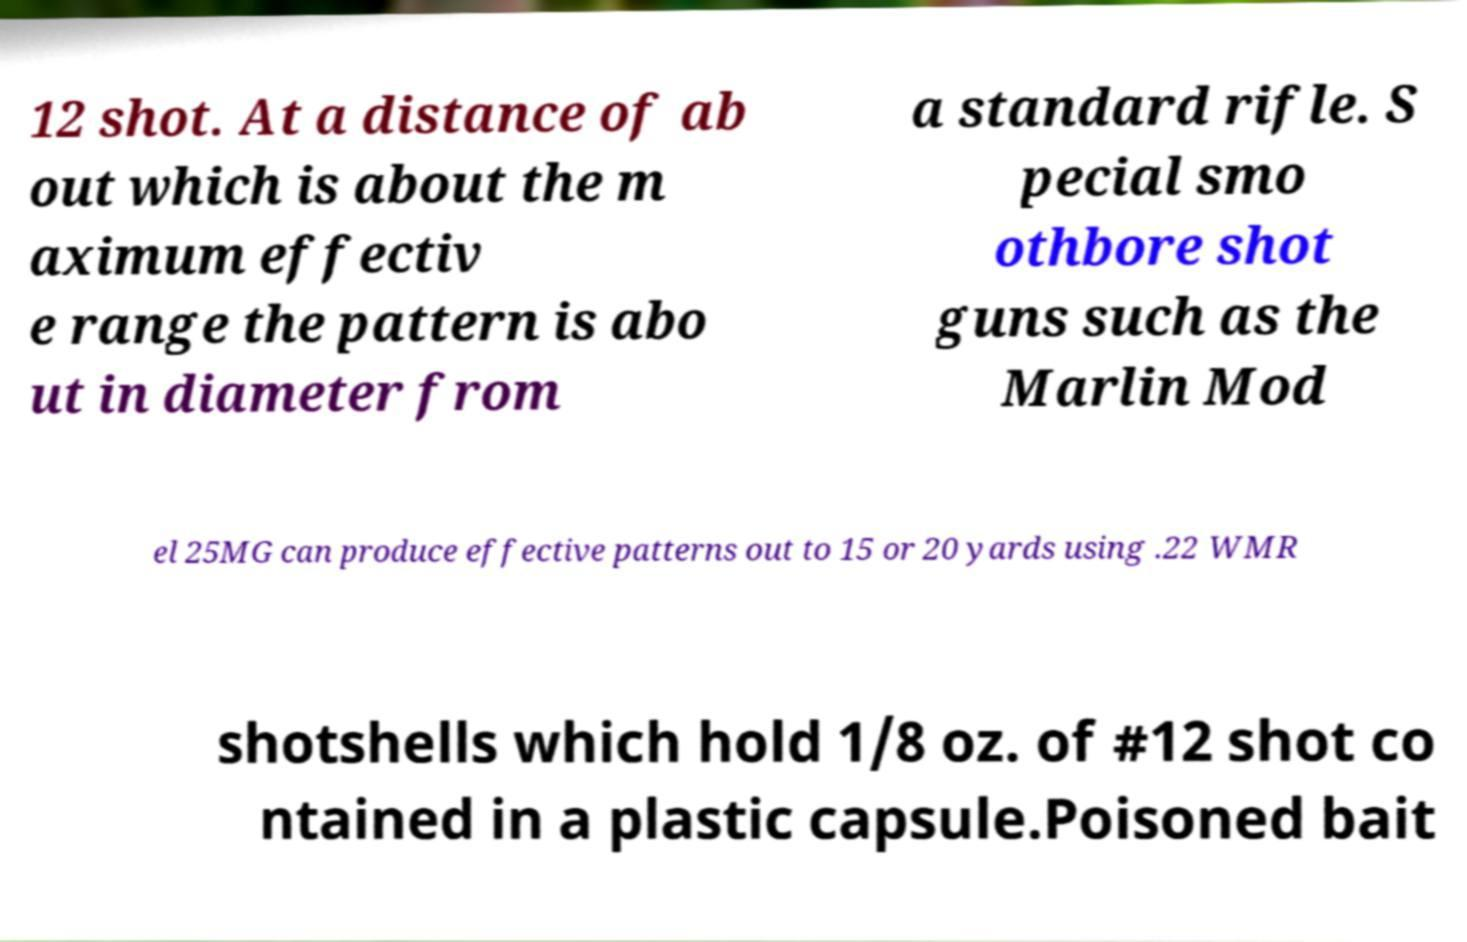I need the written content from this picture converted into text. Can you do that? 12 shot. At a distance of ab out which is about the m aximum effectiv e range the pattern is abo ut in diameter from a standard rifle. S pecial smo othbore shot guns such as the Marlin Mod el 25MG can produce effective patterns out to 15 or 20 yards using .22 WMR shotshells which hold 1/8 oz. of #12 shot co ntained in a plastic capsule.Poisoned bait 